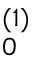<formula> <loc_0><loc_0><loc_500><loc_500>_ { 0 } ^ { ( 1 ) }</formula> 